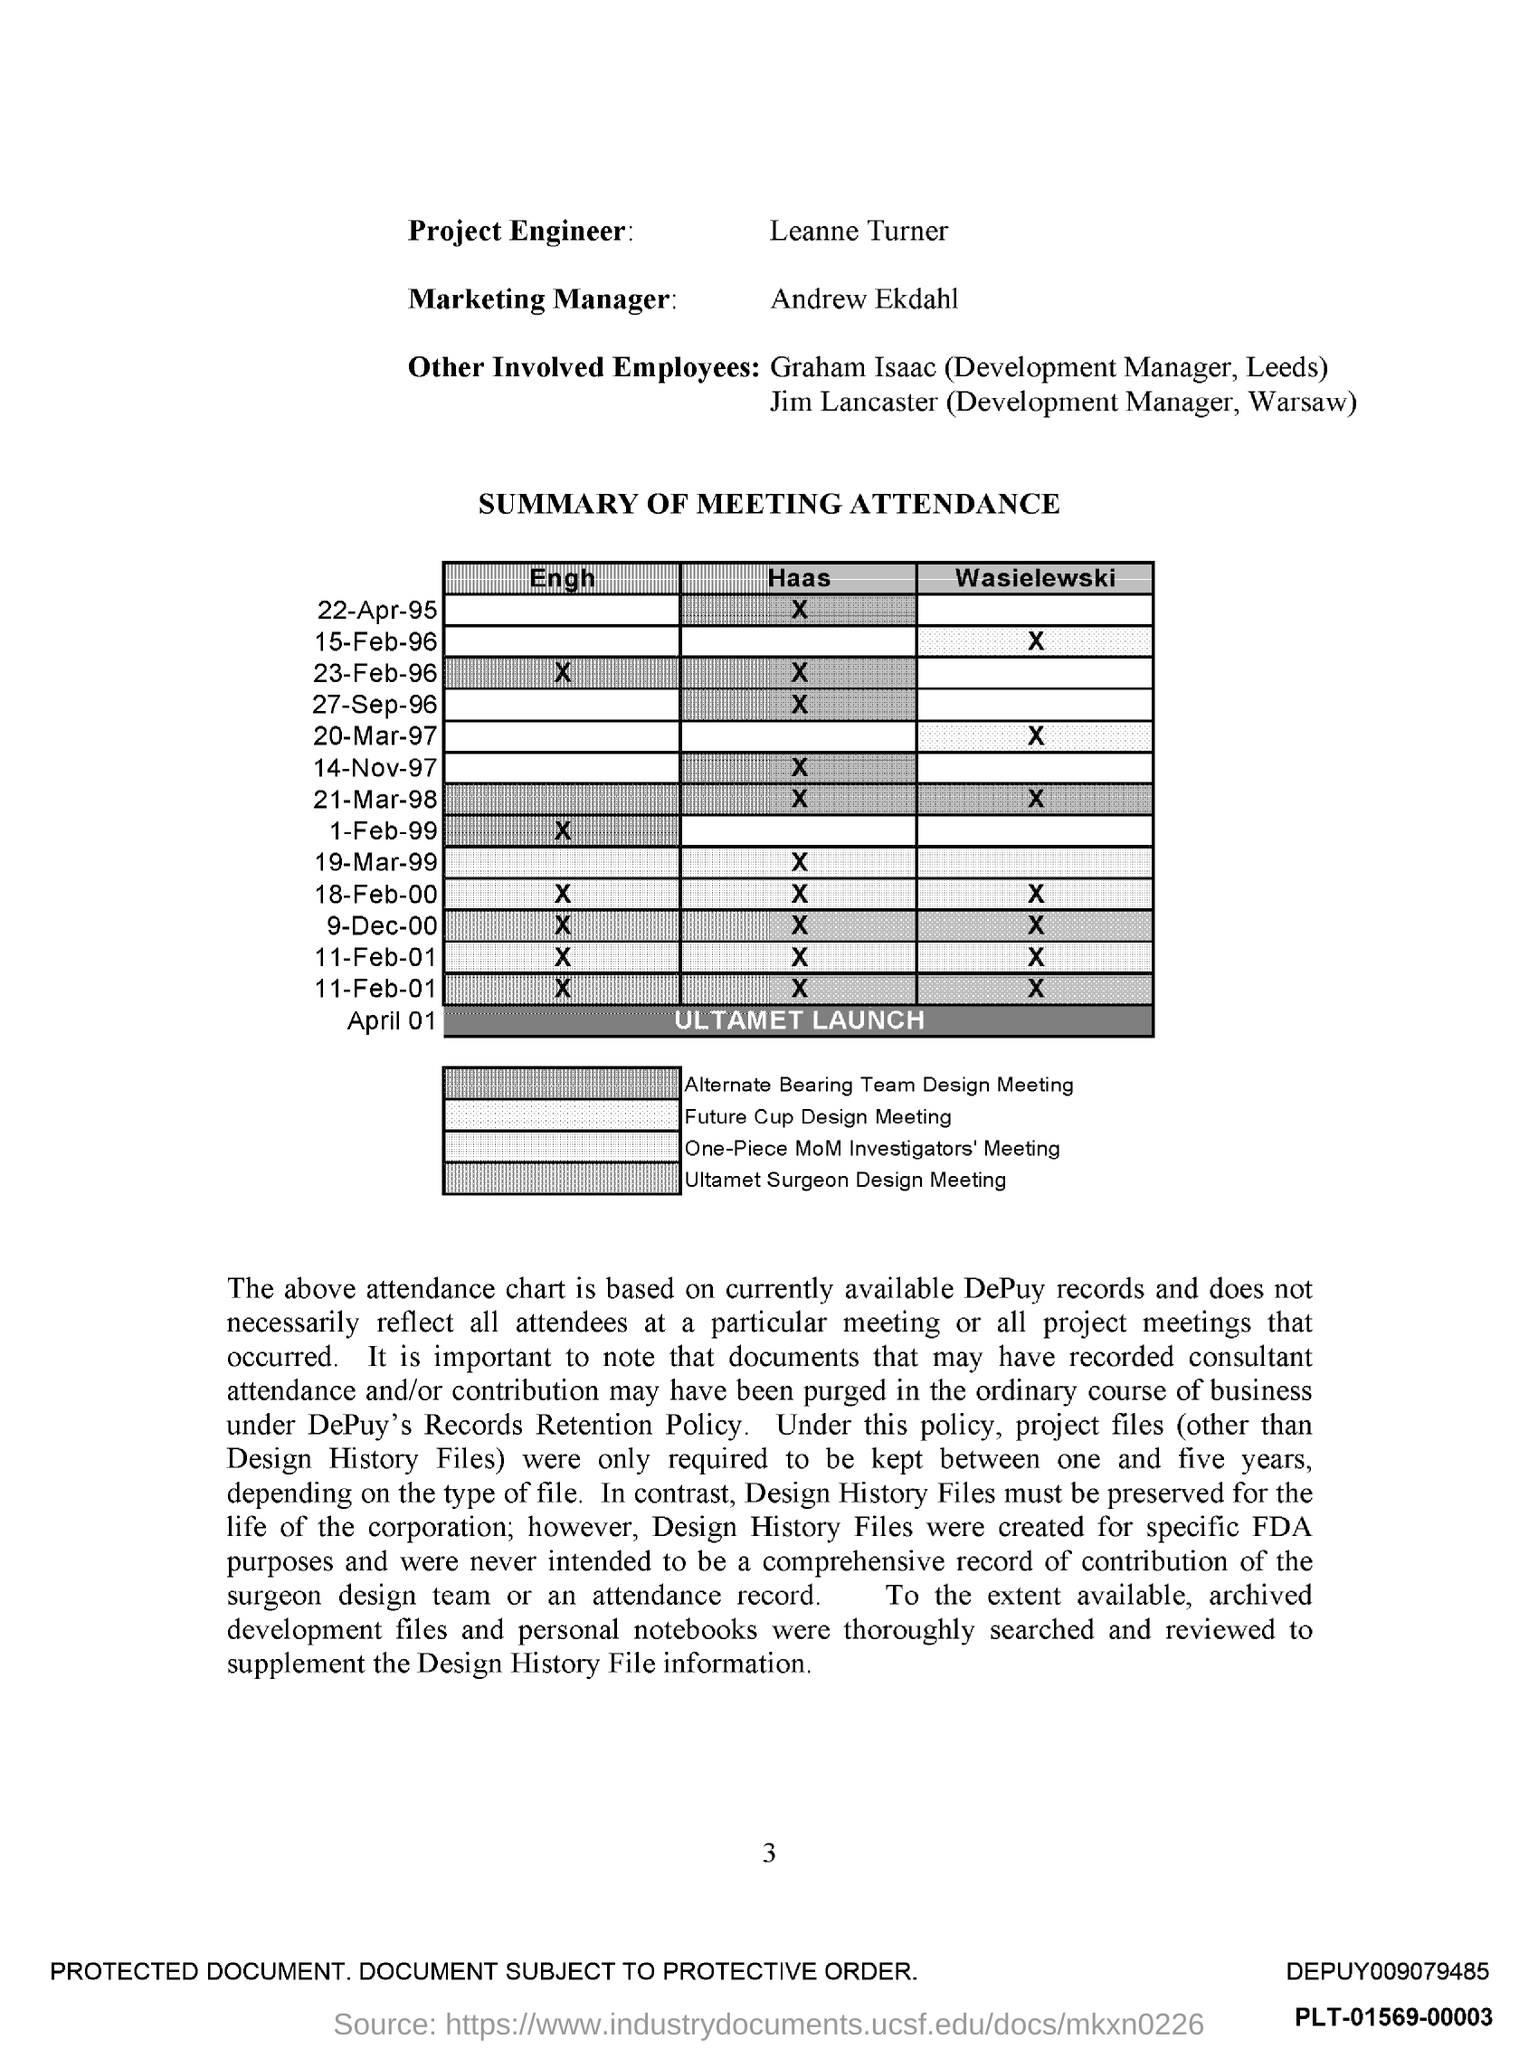Who is the Project engineer?
Give a very brief answer. Leanne Turner. Who is the marketing manager?
Provide a short and direct response. Andrew Ekdahl. 